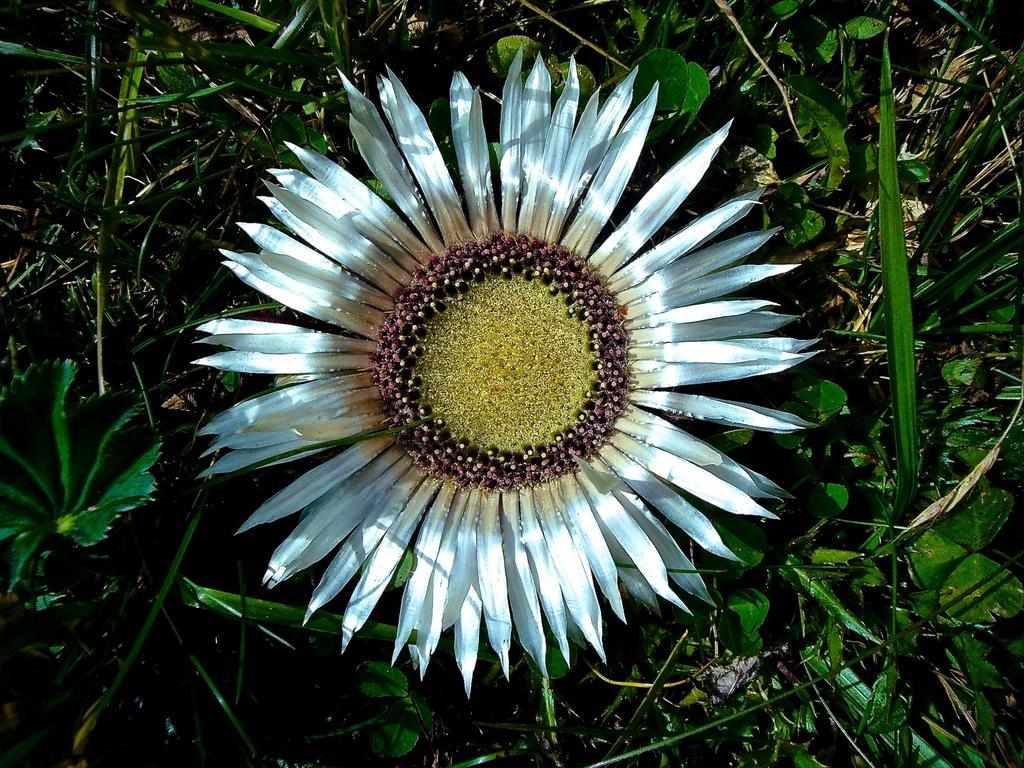Describe this image in one or two sentences. In the center of the picture there is a flower, around the flower there are plants and dry grass. 